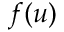<formula> <loc_0><loc_0><loc_500><loc_500>f ( u )</formula> 